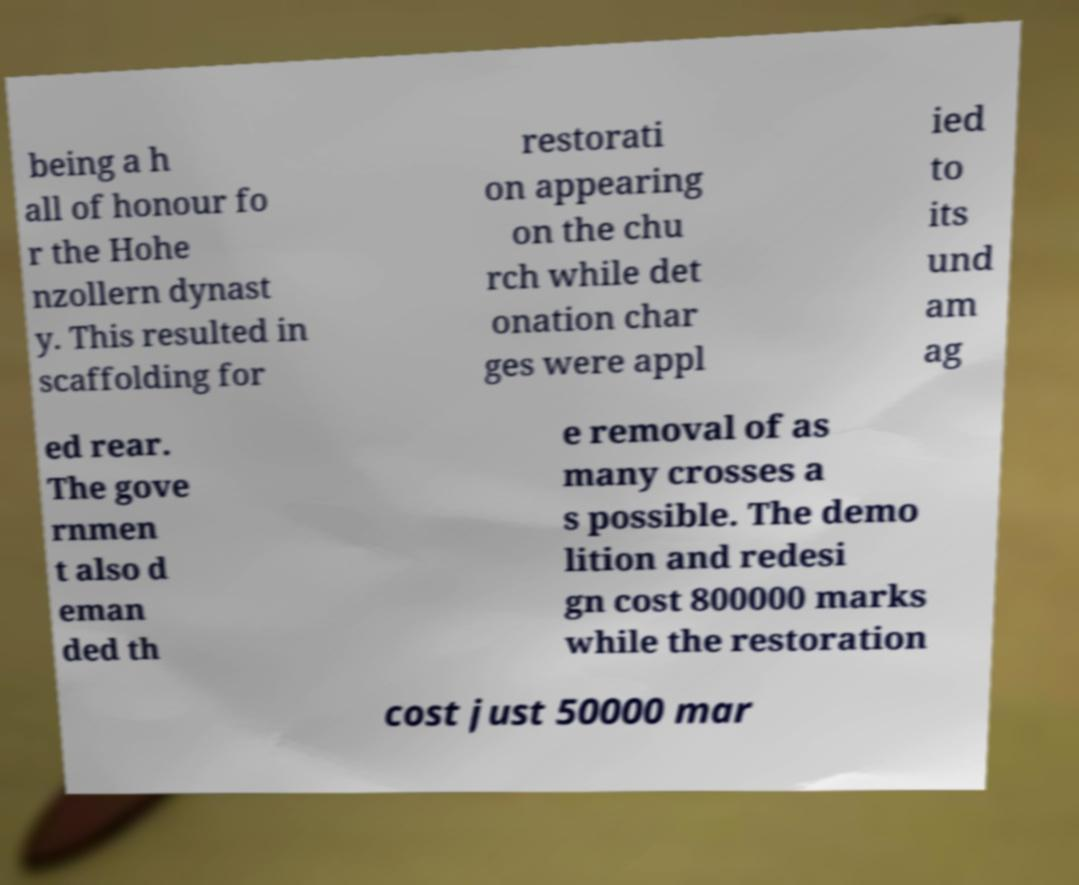Can you accurately transcribe the text from the provided image for me? being a h all of honour fo r the Hohe nzollern dynast y. This resulted in scaffolding for restorati on appearing on the chu rch while det onation char ges were appl ied to its und am ag ed rear. The gove rnmen t also d eman ded th e removal of as many crosses a s possible. The demo lition and redesi gn cost 800000 marks while the restoration cost just 50000 mar 